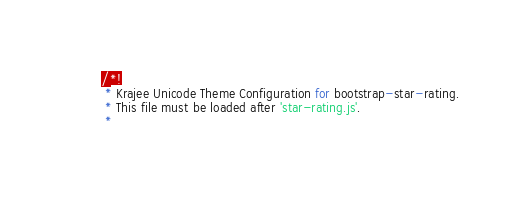Convert code to text. <code><loc_0><loc_0><loc_500><loc_500><_JavaScript_>/*!
 * Krajee Unicode Theme Configuration for bootstrap-star-rating.
 * This file must be loaded after 'star-rating.js'.
 *</code> 